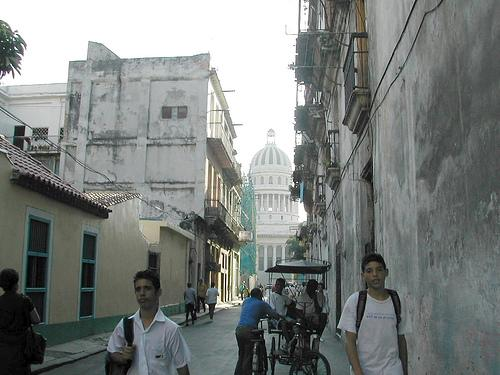Who is closest to the wall?

Choices:
A) boy
B) old woman
C) old man
D) young girl boy 